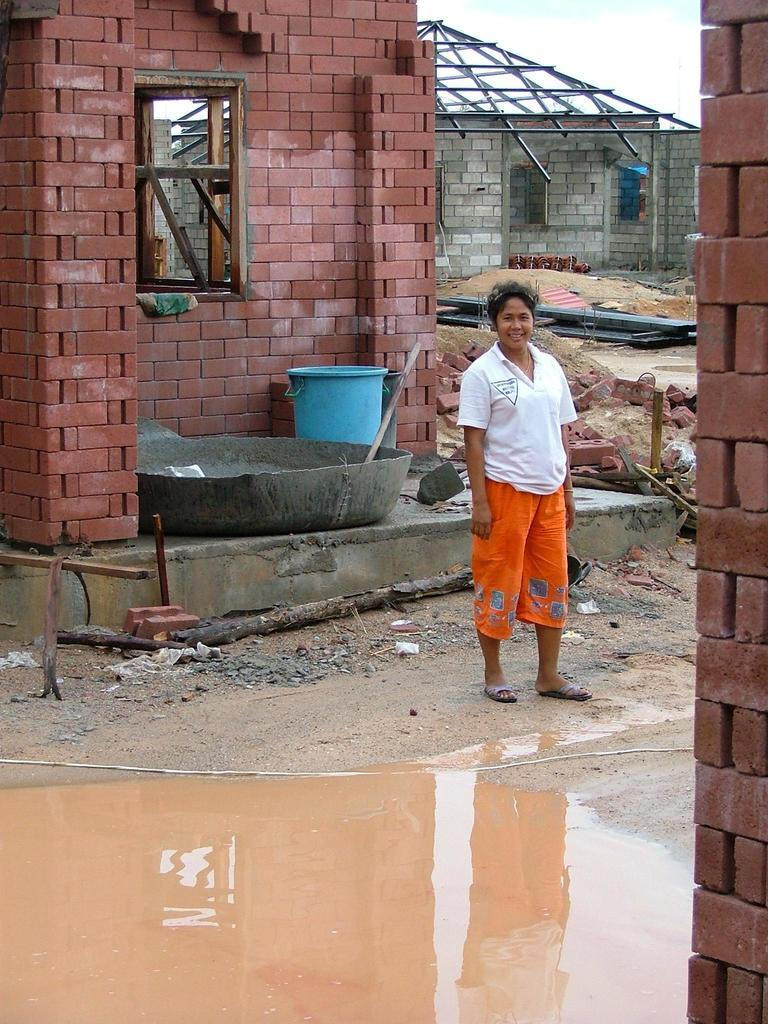Who is present in the image? There is a lady in the image. What is the lady doing in the image? The lady is standing and smiling. What can be seen on the ground in the image? There is water on the road in the image. What is visible in the background of the image? There are sheds and the sky in the background of the image. Reasoning: Let's think step by step by step in order to produce the conversation. We start by identifying the main subject in the image, which is the lady. Then, we describe her actions and expression. Next, we mention the water on the road and the sheds and sky in the background. Each question is designed to elicit a specific detail about the image that is known from the provided facts. Absurd Question/Answer: What type of calendar is hanging on the wall in the image? There is no calendar present in the image. How does the lady plan her journey in the image? The image does not show any information about the lady's journey or planning. 